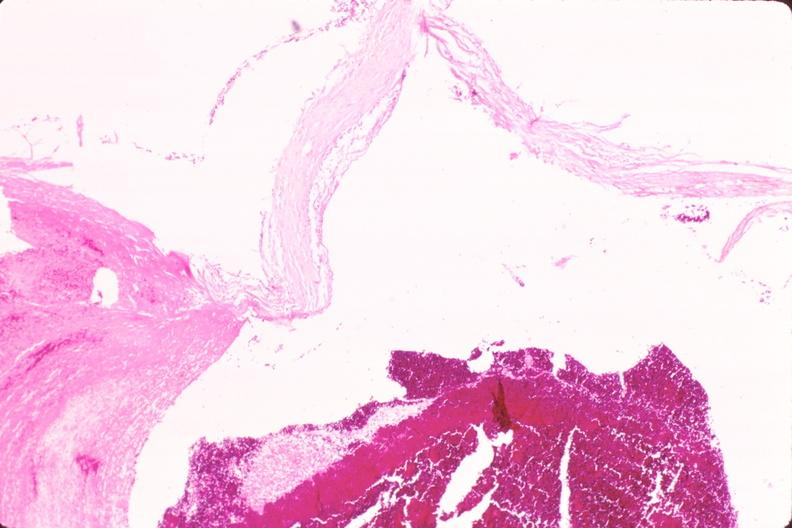s cardiovascular present?
Answer the question using a single word or phrase. Yes 